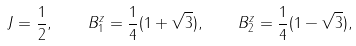<formula> <loc_0><loc_0><loc_500><loc_500>J = \frac { 1 } { 2 } , \quad B _ { 1 } ^ { z } = \frac { 1 } { 4 } ( 1 + \sqrt { 3 } ) , \quad B _ { 2 } ^ { z } = \frac { 1 } { 4 } ( 1 - \sqrt { 3 } ) ,</formula> 